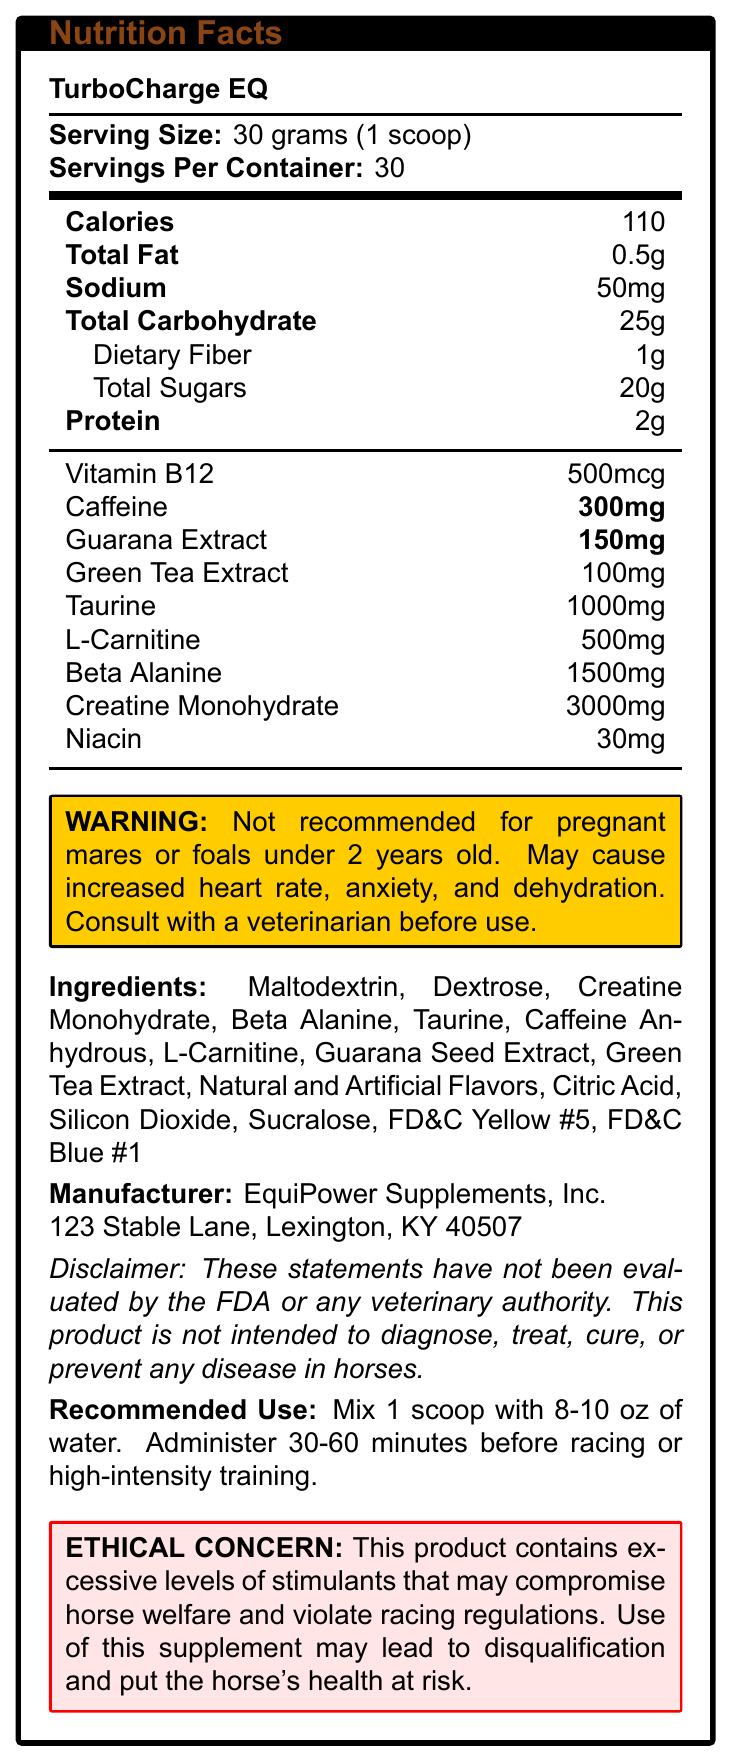what is the serving size of TurboCharge EQ? The serving size is listed under the Nutrition Facts title as "30 grams (1 scoop)."
Answer: 30 grams (1 scoop) How many servings are there per container of TurboCharge EQ? The number of servings per container is specified as 30.
Answer: 30 What is the total amount of caffeine in one serving? The document lists caffeine content as 300mg per serving.
Answer: 300mg List three stimulants found in TurboCharge EQ. The document lists caffeine, guarana extract, and green tea extract as ingredients.
Answer: Caffeine, Guarana Extract, Green Tea Extract How much creatine monohydrate is in a serving? The amount of creatine monohydrate per serving is specified as 3000mg.
Answer: 3000mg Which ingredient is present in the highest amount? A. Taurine B. Beta Alanine C. Creatine Monohydrate D. L-Carnitine Creatine Monohydrate, at 3000mg, is the ingredient present in the highest amount.
Answer: C. Creatine Monohydrate What is the primary warning given for TurboCharge EQ? A. Not recommended for use in foals B. May cause dehydration C. Consult with a veterinarian before use D. All of the above The warning consists of several statements: not recommended for pregnant mares or foals under 2 years old, may cause increased heart rate, anxiety, and dehydration, and consult with a veterinarian before use.
Answer: D. All of the above Is TurboCharge EQ recommended for pregnant mares? The warning specifically states that it is not recommended for pregnant mares.
Answer: No Summarize the potential ethical concerns associated with TurboCharge EQ. The main ethical concern is that the product contains high levels of stimulants that could adversely affect the horse's health and lead to regulatory violations.
Answer: The product contains excessive stimulants that may compromise horse welfare and violate racing regulations, potentially leading to disqualification and health risks. What are the total calories per serving? The calories per serving are listed as 110.
Answer: 110 Who manufactures TurboCharge EQ? The manufacturer is listed as EquiPower Supplements, Inc.
Answer: EquiPower Supplements, Inc. Does the document provide information on the FDA approval of TurboCharge EQ? The document contains a disclaimer stating these statements have not been evaluated by the FDA or any veterinary authority.
Answer: No What is the address of the manufacturer? The address of the manufacturer is provided as 123 Stable Lane, Lexington, KY 40507.
Answer: 123 Stable Lane, Lexington, KY 40507 What should be done before administering TurboCharge EQ according to the recommended use? The document states that you should mix 1 scoop with 8-10 oz of water before administering.
Answer: Mix 1 scoop with 8-10 oz of water 